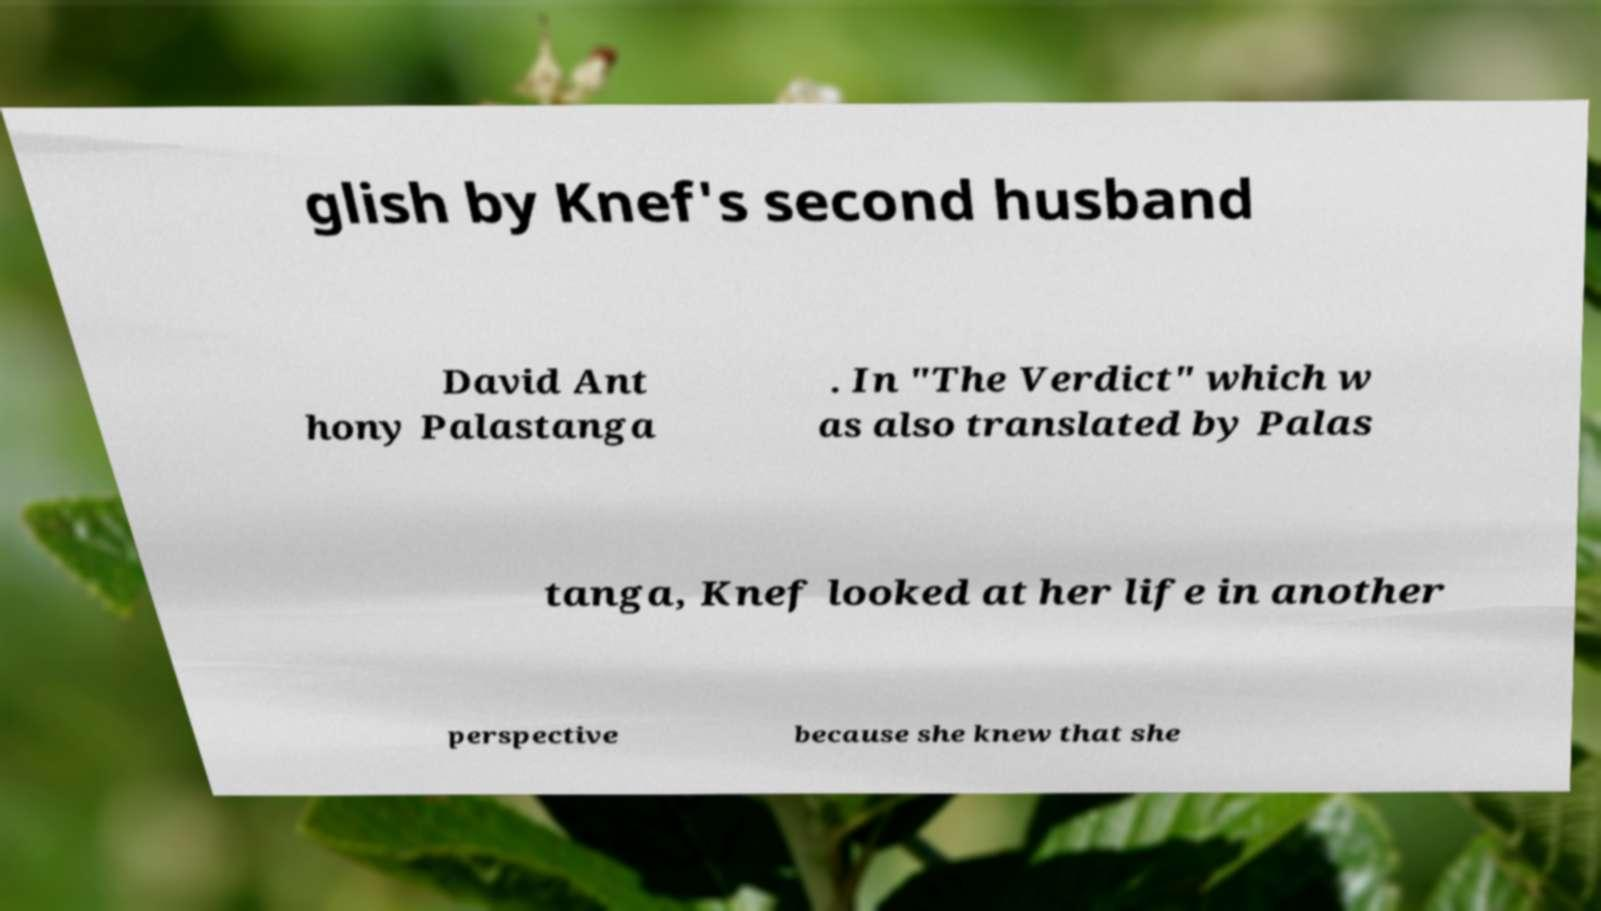There's text embedded in this image that I need extracted. Can you transcribe it verbatim? glish by Knef's second husband David Ant hony Palastanga . In "The Verdict" which w as also translated by Palas tanga, Knef looked at her life in another perspective because she knew that she 